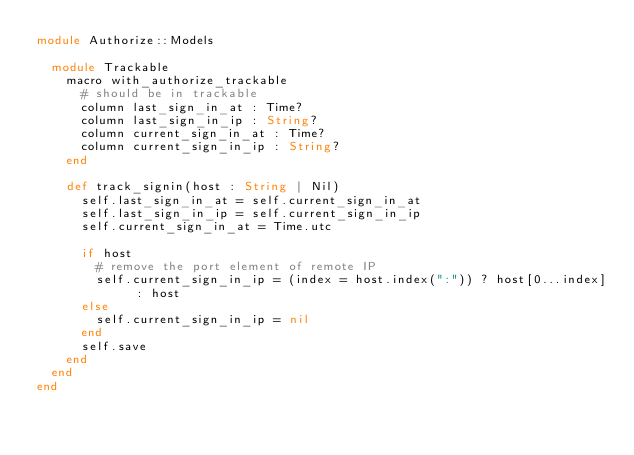Convert code to text. <code><loc_0><loc_0><loc_500><loc_500><_Crystal_>module Authorize::Models

  module Trackable
    macro with_authorize_trackable
      # should be in trackable
      column last_sign_in_at : Time?
      column last_sign_in_ip : String?
      column current_sign_in_at : Time?
      column current_sign_in_ip : String?
    end

    def track_signin(host : String | Nil)
      self.last_sign_in_at = self.current_sign_in_at
      self.last_sign_in_ip = self.current_sign_in_ip
      self.current_sign_in_at = Time.utc
      
      if host
        # remove the port element of remote IP
        self.current_sign_in_ip = (index = host.index(":")) ? host[0...index] : host
      else
        self.current_sign_in_ip = nil
      end
      self.save
    end
  end
end</code> 